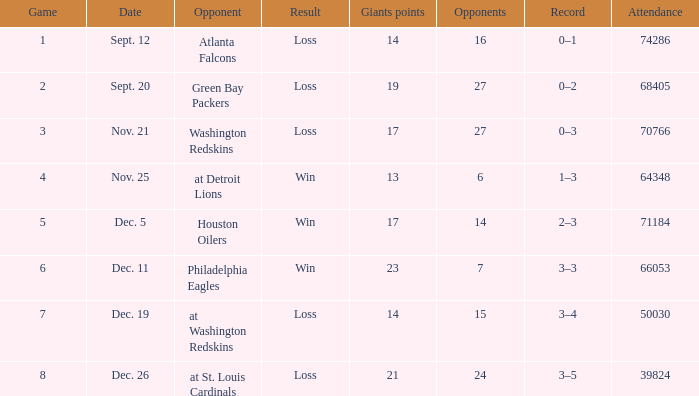What is the record when competing against the washington redskins? 0–3. 